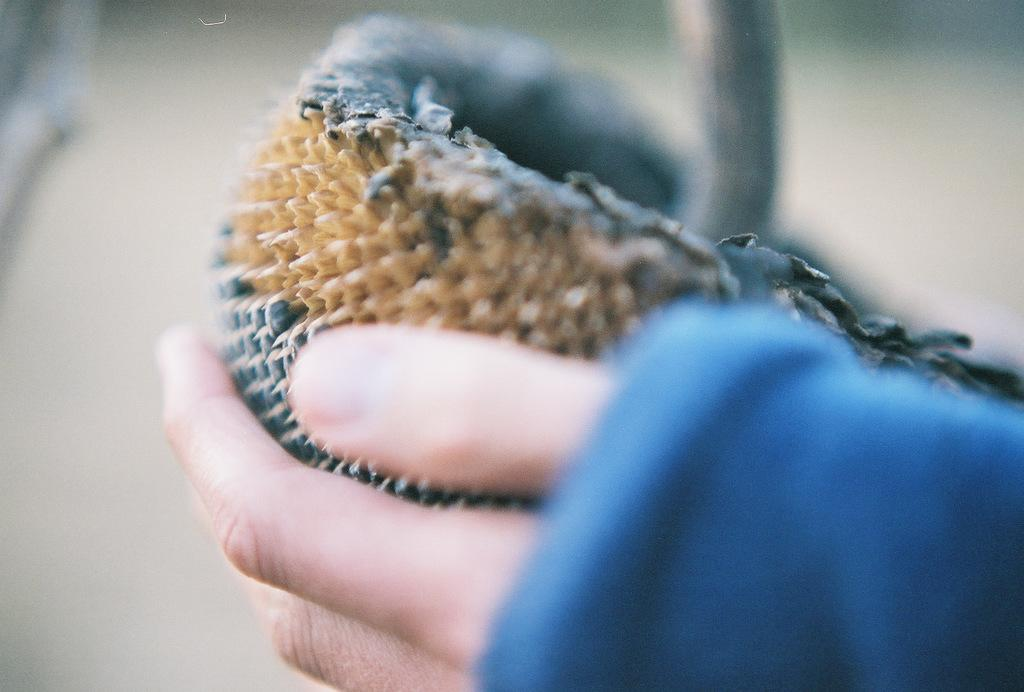What is the main subject of the image? There is a person in the image. What is the person doing in the image? The person is holding an object. Can you describe the background of the image? The background of the image is blurred. Is the person in the image playing with steam? There is no steam present in the image, and the person is not playing with any steam. 